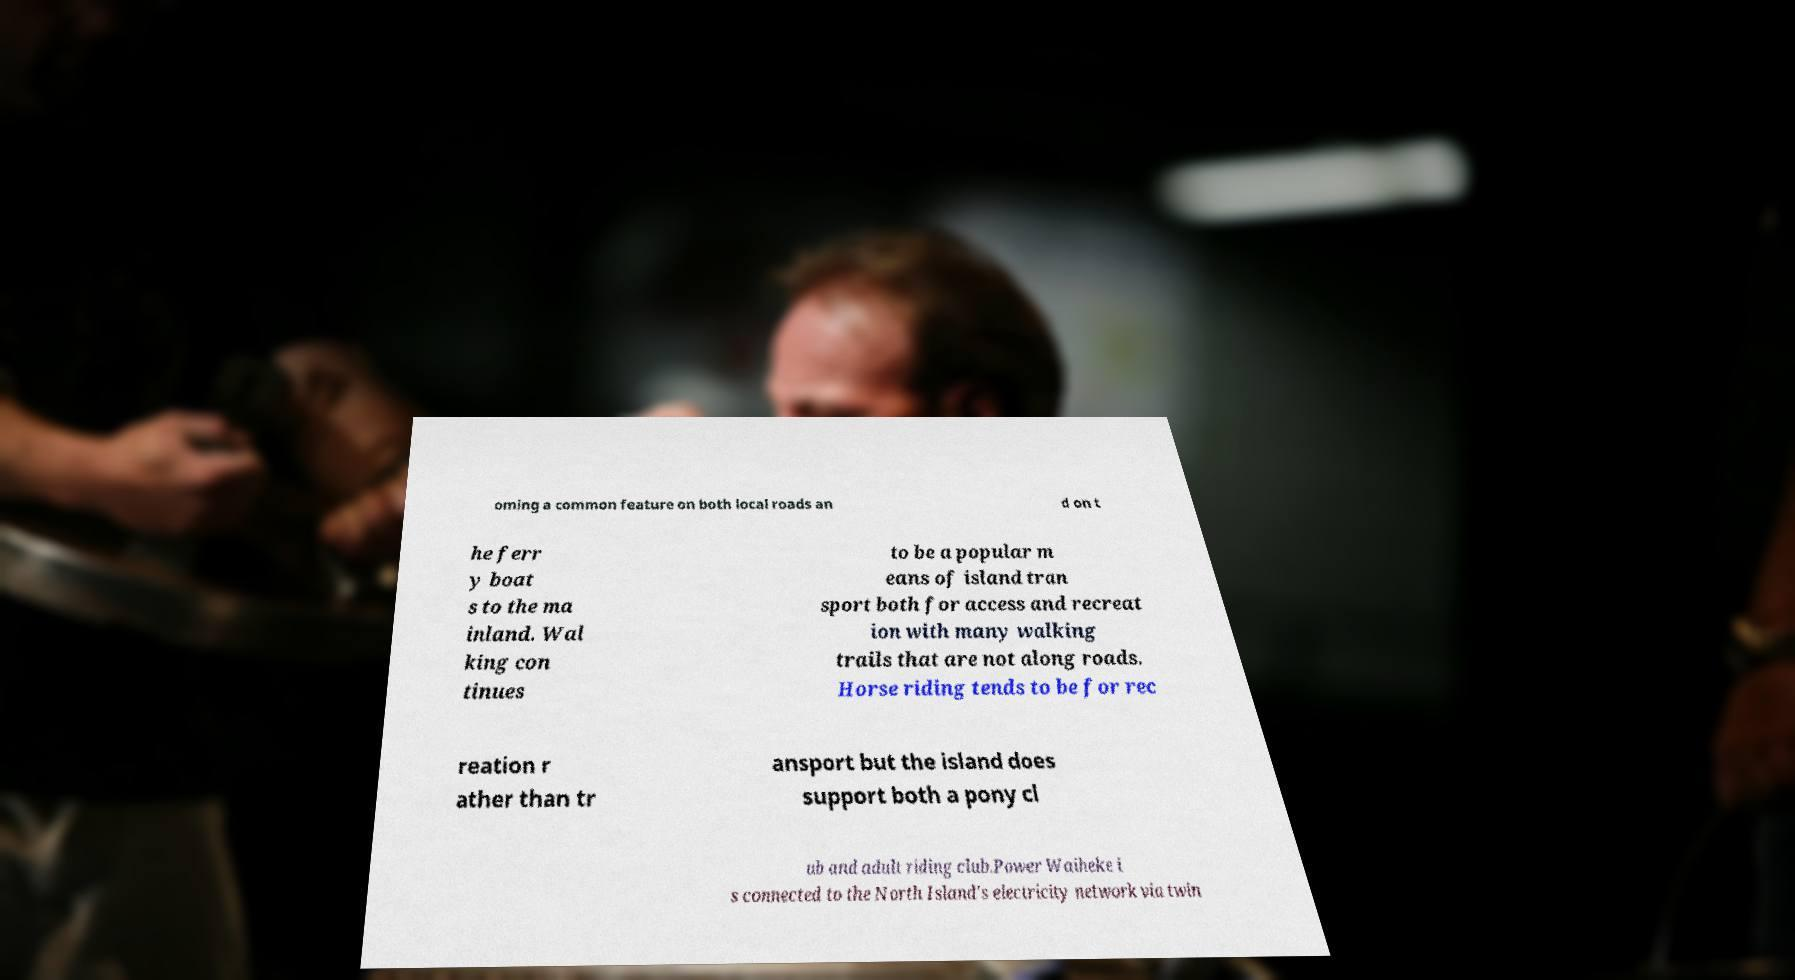Please read and relay the text visible in this image. What does it say? oming a common feature on both local roads an d on t he ferr y boat s to the ma inland. Wal king con tinues to be a popular m eans of island tran sport both for access and recreat ion with many walking trails that are not along roads. Horse riding tends to be for rec reation r ather than tr ansport but the island does support both a pony cl ub and adult riding club.Power Waiheke i s connected to the North Island's electricity network via twin 